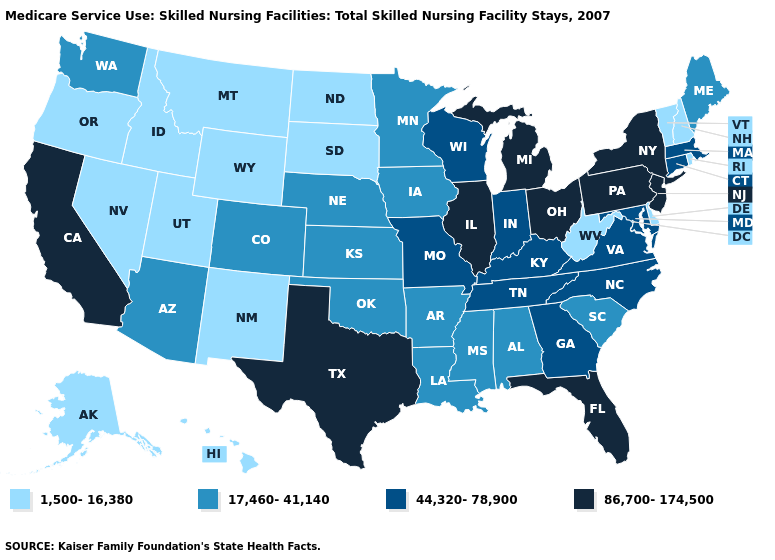Name the states that have a value in the range 17,460-41,140?
Keep it brief. Alabama, Arizona, Arkansas, Colorado, Iowa, Kansas, Louisiana, Maine, Minnesota, Mississippi, Nebraska, Oklahoma, South Carolina, Washington. Does New York have the lowest value in the Northeast?
Answer briefly. No. What is the value of Illinois?
Give a very brief answer. 86,700-174,500. What is the value of South Dakota?
Give a very brief answer. 1,500-16,380. Name the states that have a value in the range 86,700-174,500?
Quick response, please. California, Florida, Illinois, Michigan, New Jersey, New York, Ohio, Pennsylvania, Texas. What is the value of Kansas?
Keep it brief. 17,460-41,140. What is the value of Nevada?
Write a very short answer. 1,500-16,380. Name the states that have a value in the range 44,320-78,900?
Concise answer only. Connecticut, Georgia, Indiana, Kentucky, Maryland, Massachusetts, Missouri, North Carolina, Tennessee, Virginia, Wisconsin. Which states hav the highest value in the Northeast?
Quick response, please. New Jersey, New York, Pennsylvania. Name the states that have a value in the range 44,320-78,900?
Write a very short answer. Connecticut, Georgia, Indiana, Kentucky, Maryland, Massachusetts, Missouri, North Carolina, Tennessee, Virginia, Wisconsin. What is the highest value in the South ?
Write a very short answer. 86,700-174,500. Does Wisconsin have the highest value in the MidWest?
Short answer required. No. Does Arizona have the same value as Arkansas?
Be succinct. Yes. Does the map have missing data?
Give a very brief answer. No. Which states have the lowest value in the South?
Concise answer only. Delaware, West Virginia. 